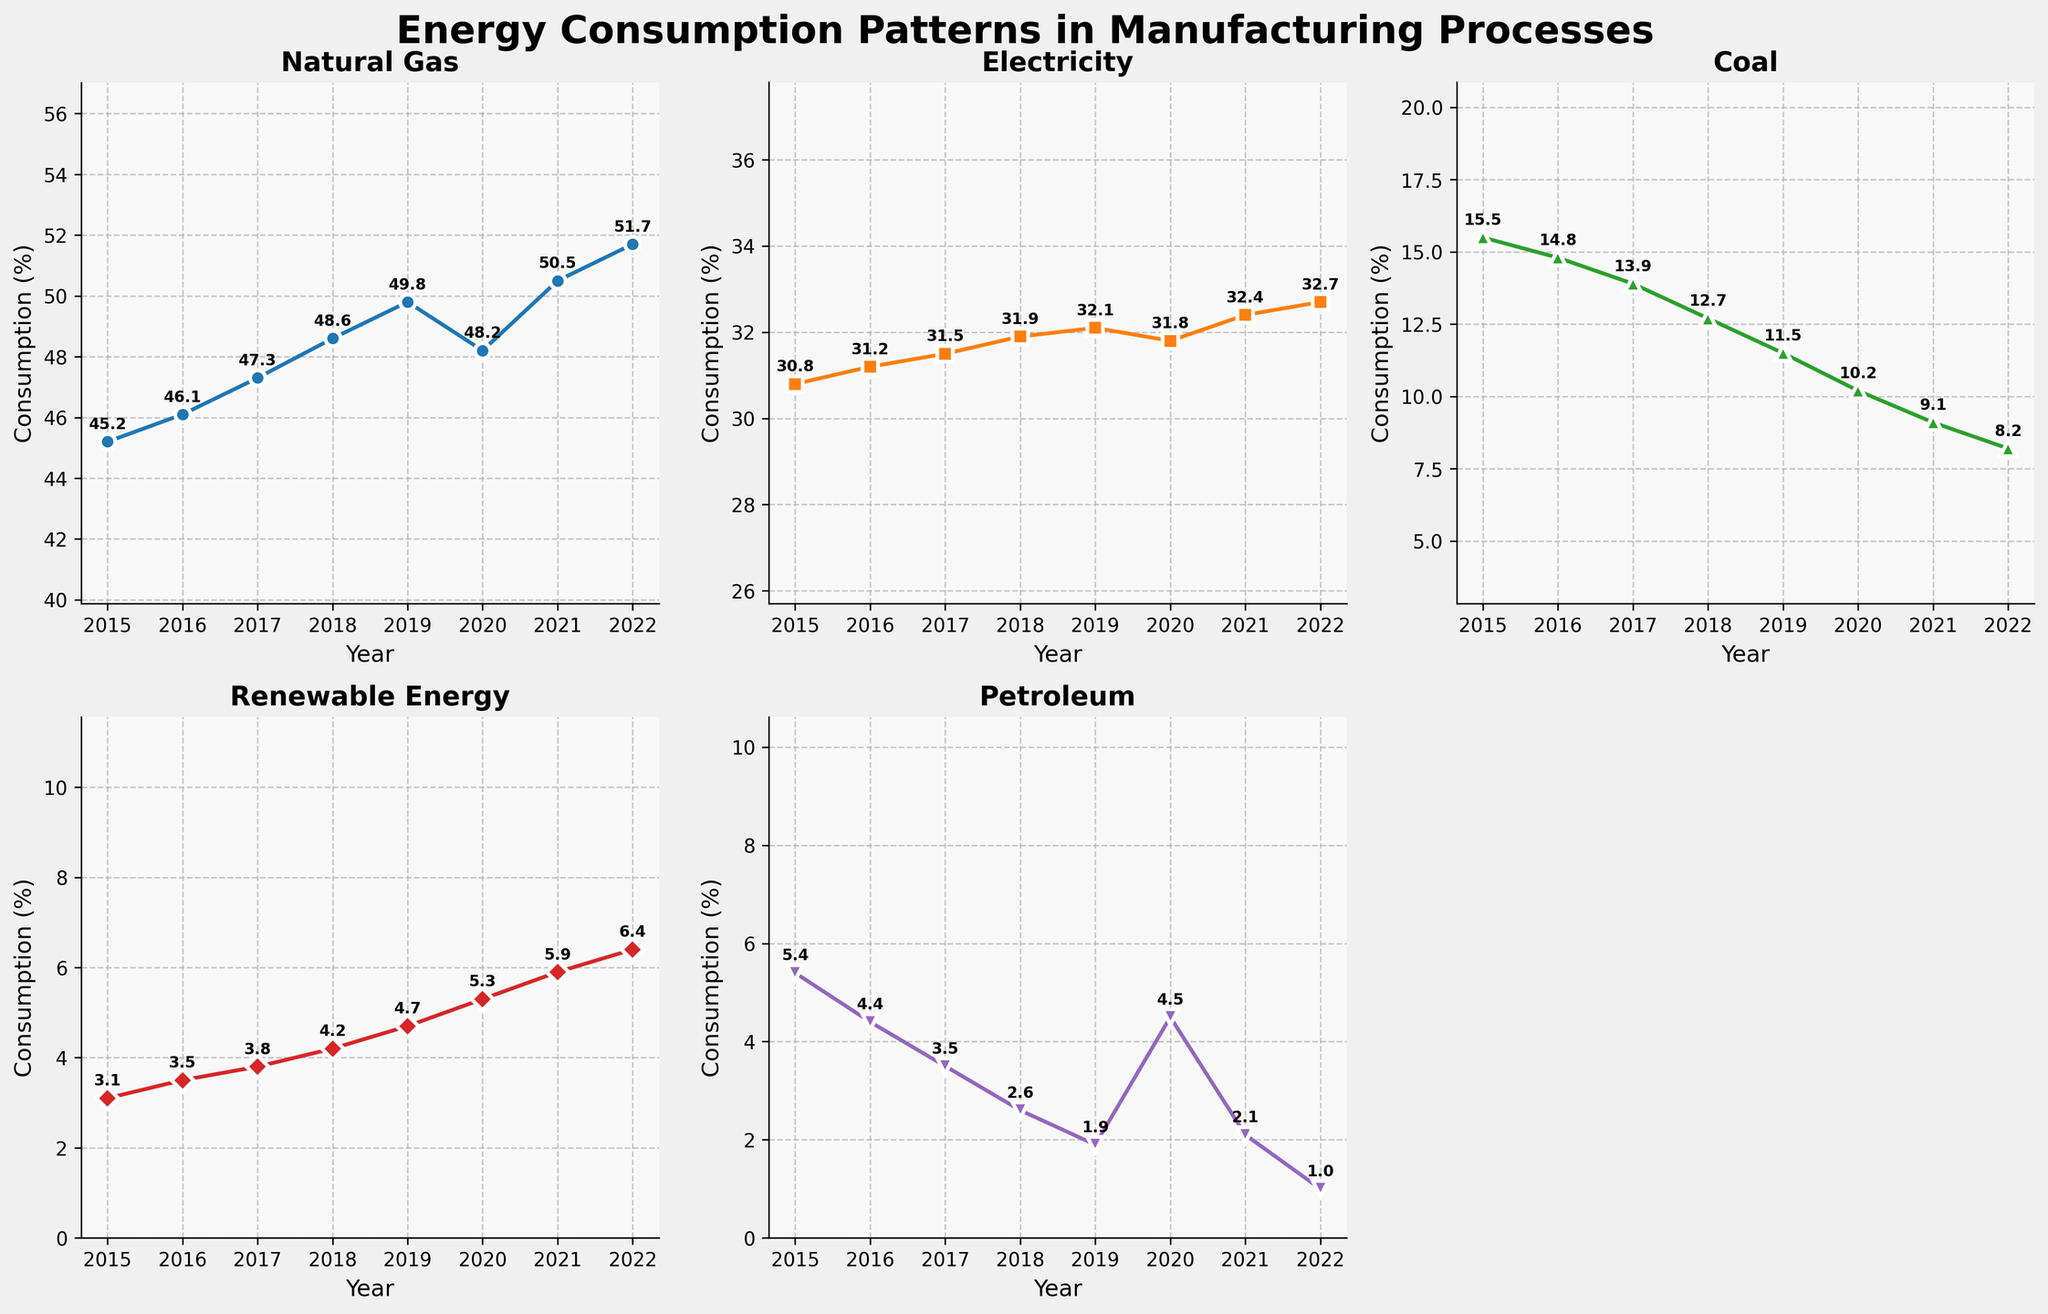What is the title of the figure? The title is shown at the top center of the figure in bold and larger font, indicating what the plot is about.
Answer: Energy Consumption Patterns in Manufacturing Processes In which year did renewable energy consumption surpass 5%? Look at the subplot for "Renewable Energy" and find the year when the consumption percentage exceeds 5%.
Answer: 2020 How did the consumption of coal change from 2015 to 2022? Check the subplot for "Coal" and compare the percentage in 2015 with that in 2022. There is a clear decline.
Answer: It decreased from 15.5% to 8.2% Which energy source had the greatest increase in consumption from 2015 to 2022? Look at all subplots and compare the changes in consumption percentages between 2015 and 2022. Renewable energy shows the most significant rise.
Answer: Renewable Energy What was the average percentage consumption of electricity between 2015 and 2022? Add the consumption percentages of electricity from 2015 to 2022, and then divide by the number of years (8). The values are: 30.8, 31.2, 31.5, 31.9, 32.1, 31.8, 32.4, 32.7. The sum is 254.4 and the average is 254.4 / 8.
Answer: 31.8% Which year showed a decrease in natural gas consumption compared to the previous year? Identify a year in the subplot for "Natural Gas" where the plotted line shows a drop from the year before. 2020 shows a decrease compared to 2019.
Answer: 2020 How much did petroleum consumption drop from its highest to its lowest value across the years? Locate the highest (2015) and lowest (2022) values in the subplot for "Petroleum". The highest is 5.4% in 2015, and the lowest is 1.0% in 2022. The difference is 5.4% - 1.0%.
Answer: 4.4% Is there any year where the consumption of coal and petroleum was equal? Compare the values in the subplots for "Coal" and "Petroleum" across all years. The values are never equal, so the answer is no.
Answer: No Compare the trend of renewable energy consumption with petroleum consumption from 2015 to 2022. In the subplot for "Renewable Energy", there is a consistent upward trend. In contrast, the subplot for "Petroleum" shows a downward trend over the same period.
Answer: Renewable energy increased, while petroleum decreased What is the range of natural gas consumption percentages across the years shown? Find the minimum (2015 at 45.2%) and maximum (2022 at 51.7%) values in the "Natural Gas" subplot. The range is the difference between these values.
Answer: 6.5% 